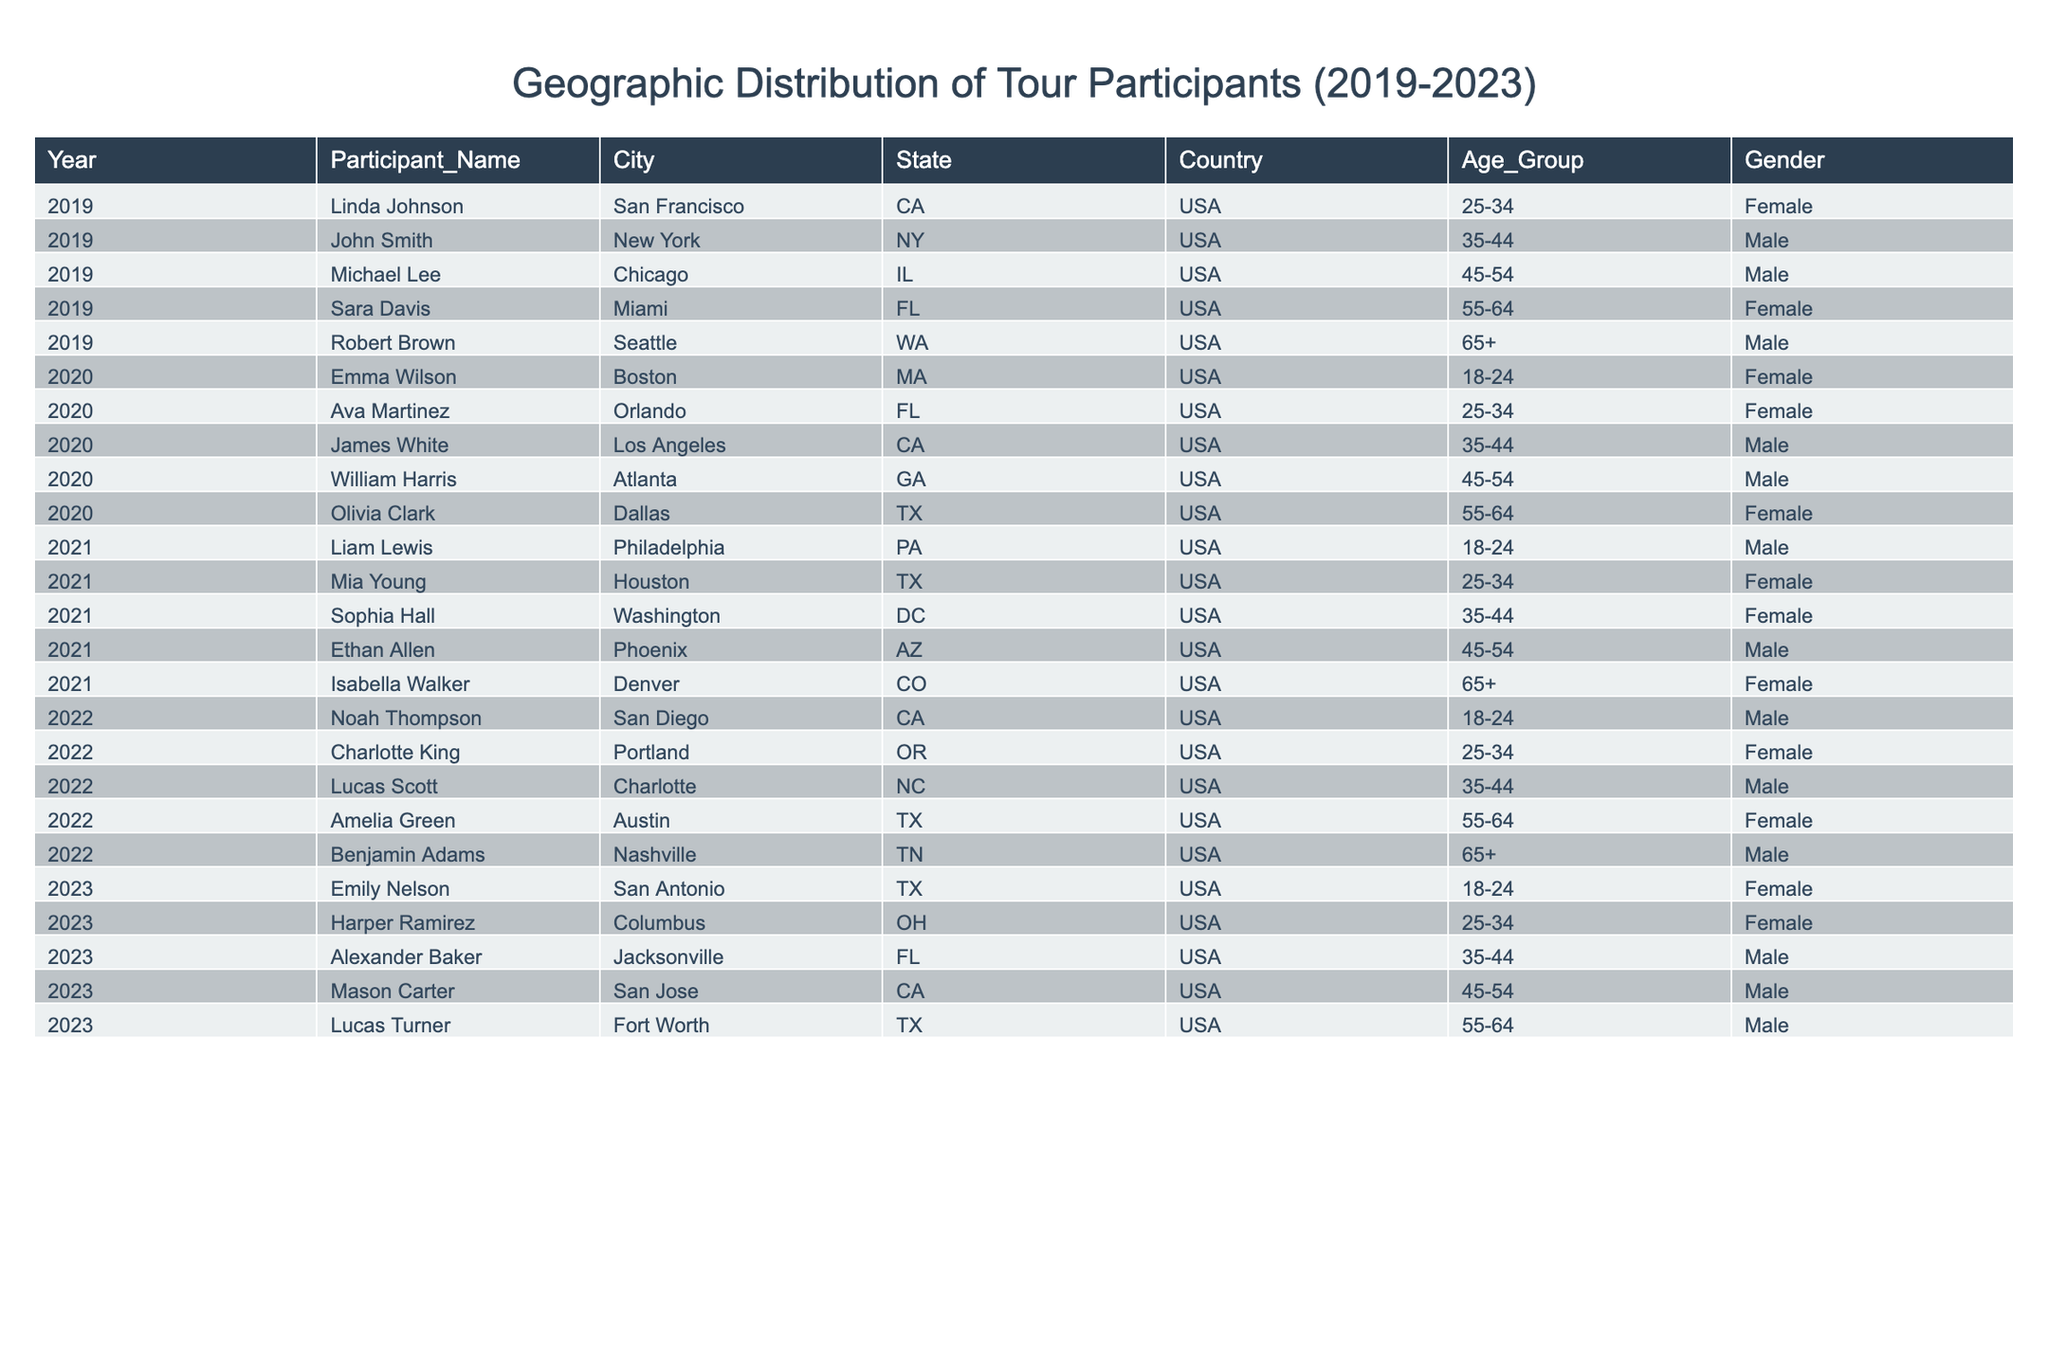What is the total number of participants from California over the five years? The data shows that California had participants in 2019 (San Francisco), 2020 (Los Angeles, Orlando), 2021 (Denver), 2022 (San Diego), and 2023 (San Jose). Summing these gives us 5 participants from California.
Answer: 5 Which year had the highest representation of female participants? By examining the counts of female participants per year: 2019 (2), 2020 (2), 2021 (3), 2022 (2), and 2023 (2). The year 2021 had the highest count with 3 female participants.
Answer: 2021 How many participants aged 25-34 were there in total across all years? The age group 25-34 includes participants from 2019 (1), 2020 (1), 2021 (1), 2022 (1), and 2023 (1). Summing these gives us a total of 5 participants aged 25-34.
Answer: 5 True or False: There were more male participants than female participants in 2020. In 2020, there were 3 males (James White, William Harris) and 3 females (Emma Wilson, Ava Martinez, Olivia Clark). Since they are equal, the statement is false.
Answer: False In which state did the youngest participant from the data come from? The youngest participant is Emma Wilson, aged 18-24, from Boston, MA in 2020. Thus, she is the youngest and represents Massachusetts.
Answer: Massachusetts Calculate the average age group representation per year. We count the number of participants each year: 2019 (5), 2020 (5), 2021 (5), 2022 (5), 2023 (5). The total participants across 5 years is 25, therefore the average is 25/5 = 5 participants per year.
Answer: 5 Which city had the highest number of participants over the five years? Analyzing the data shows that Houston, TX had 2 participants (Ethan Allen in 2021 and Mia Young in 2021), while other cities had either 1 or no participants. Thus, Houston had the highest representation.
Answer: Houston What percentage of participants were from Florida? The total number of participants is 25. The participants from Florida included Sara Davis (2019), Olivia Clark (2020), Noah Thompson (2021), Alexander Baker (2023), and Emily Nelson (2023) totaling 4 participants. To get the percentage: (4/25) * 100 = 16%.
Answer: 16% Identify the two states that had representatives in the youngest age group (18-24). The participants in the 18-24 age group include Emma Wilson from Massachusetts (2020) and Liam Lewis from Pennsylvania (2021). Therefore, the two states represented are Massachusetts and Pennsylvania.
Answer: Massachusetts, Pennsylvania What is the total number of participants aged 65 and older across all years? The data shows that 65+ participants are from 2019 (Seattle), 2021 (Denver), 2022 (Nashville), and 2023 (Fort Worth). This gives us a total of 4 participants aged 65 and older.
Answer: 4 Which gender had more participants in the 35-44 age group? Counting participants in the 35-44 group reveals there are 4 males (John Smith, William Harris, Sophia Hall, Alexander Baker) and 3 females (Charlotte King, Lucas Scott, Harper Ramirez). Thus, males had more participants.
Answer: Male 